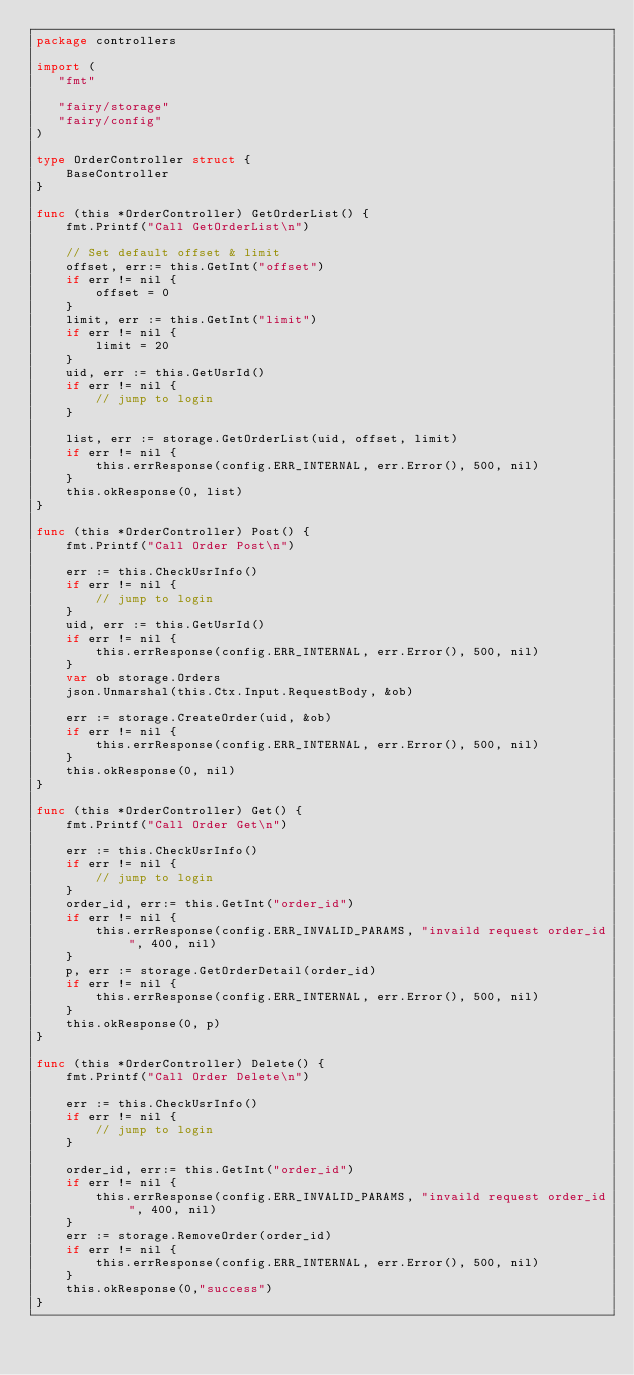Convert code to text. <code><loc_0><loc_0><loc_500><loc_500><_Go_>package controllers

import (
   "fmt"

   "fairy/storage"
   "fairy/config"
)

type OrderController struct {
    BaseController
}

func (this *OrderController) GetOrderList() {
    fmt.Printf("Call GetOrderList\n")

    // Set default offset & limit
    offset, err:= this.GetInt("offset")
    if err != nil {
        offset = 0
    }
    limit, err := this.GetInt("limit")
    if err != nil {
        limit = 20
    }
    uid, err := this.GetUsrId()
    if err != nil {
        // jump to login
    }

    list, err := storage.GetOrderList(uid, offset, limit)
    if err != nil {
        this.errResponse(config.ERR_INTERNAL, err.Error(), 500, nil)
    }
    this.okResponse(0, list)
}

func (this *OrderController) Post() {
    fmt.Printf("Call Order Post\n")

    err := this.CheckUsrInfo()
    if err != nil {
        // jump to login
    }
    uid, err := this.GetUsrId()
    if err != nil {
        this.errResponse(config.ERR_INTERNAL, err.Error(), 500, nil)
    }
    var ob storage.Orders
    json.Unmarshal(this.Ctx.Input.RequestBody, &ob)

    err := storage.CreateOrder(uid, &ob)
    if err != nil {
        this.errResponse(config.ERR_INTERNAL, err.Error(), 500, nil)
    }
    this.okResponse(0, nil)
}

func (this *OrderController) Get() {
    fmt.Printf("Call Order Get\n")

    err := this.CheckUsrInfo()
    if err != nil {
        // jump to login
    }
    order_id, err:= this.GetInt("order_id")
    if err != nil {
        this.errResponse(config.ERR_INVALID_PARAMS, "invaild request order_id", 400, nil)
    }
    p, err := storage.GetOrderDetail(order_id)
    if err != nil {
        this.errResponse(config.ERR_INTERNAL, err.Error(), 500, nil)
    }
    this.okResponse(0, p)
}

func (this *OrderController) Delete() {
    fmt.Printf("Call Order Delete\n")

    err := this.CheckUsrInfo()
    if err != nil {
        // jump to login
    }

    order_id, err:= this.GetInt("order_id")
    if err != nil {
        this.errResponse(config.ERR_INVALID_PARAMS, "invaild request order_id", 400, nil)
    }
    err := storage.RemoveOrder(order_id)
    if err != nil {
        this.errResponse(config.ERR_INTERNAL, err.Error(), 500, nil)
    }
    this.okResponse(0,"success")
}
</code> 